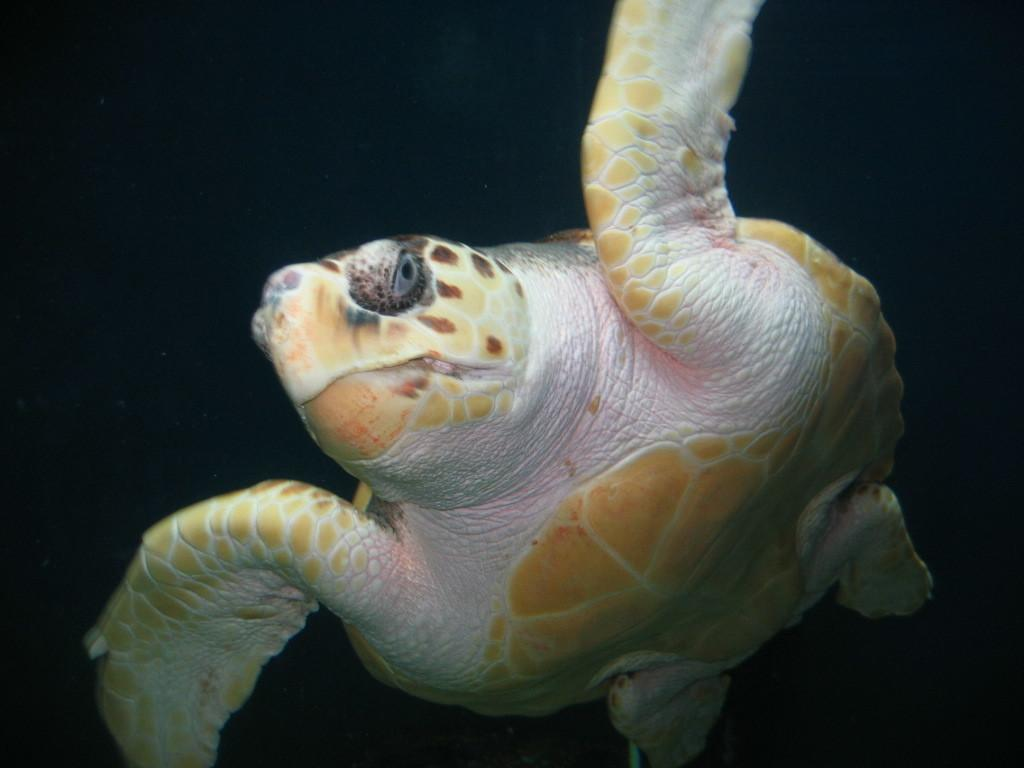What type of animal is in the image? There is a tortoise in the image. What color is the background of the image? The background of the image is black. What type of beetle is sitting next to the tortoise in the image? There is no beetle present in the image; only the tortoise is visible. Can you tell me how the tortoise is related to the person in the image? There is no person present in the image, so it is not possible to determine any relationships. 